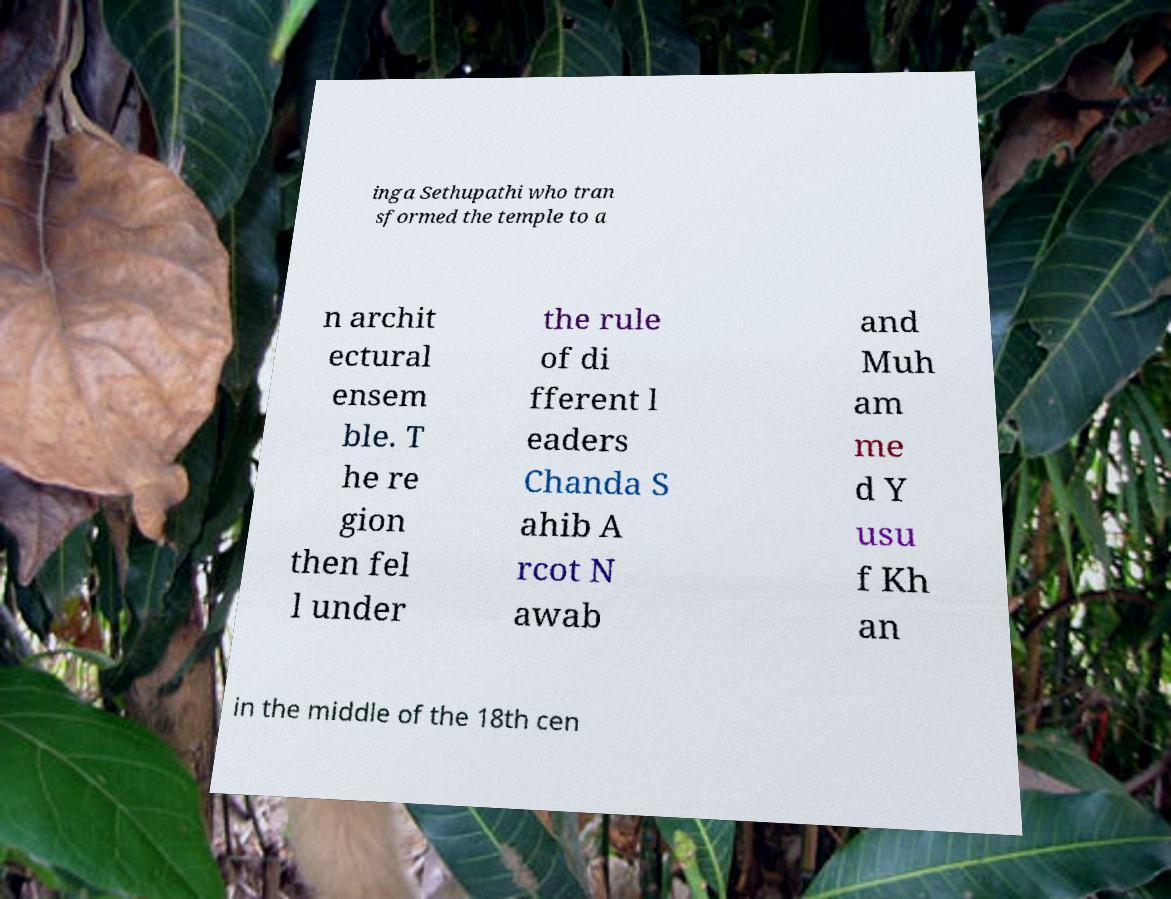Could you assist in decoding the text presented in this image and type it out clearly? inga Sethupathi who tran sformed the temple to a n archit ectural ensem ble. T he re gion then fel l under the rule of di fferent l eaders Chanda S ahib A rcot N awab and Muh am me d Y usu f Kh an in the middle of the 18th cen 